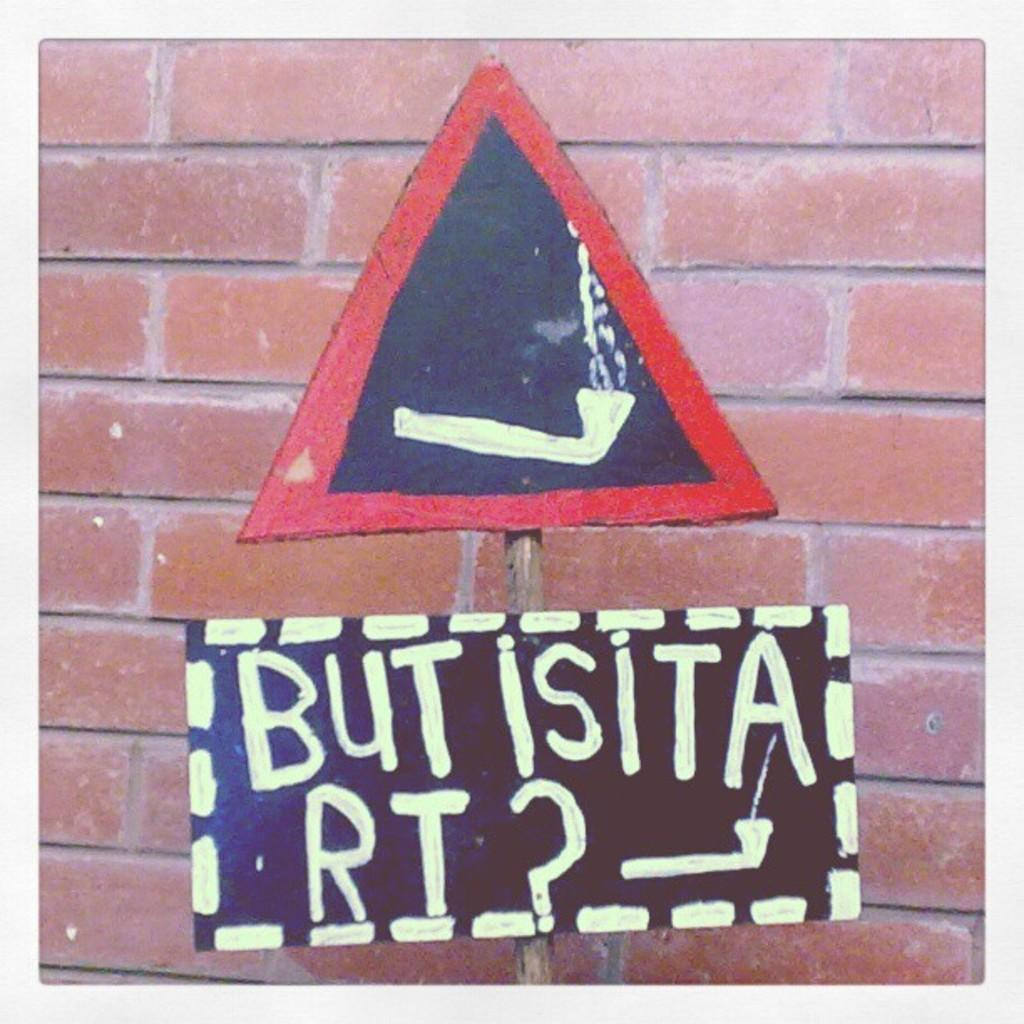What type of structure is visible in the image? There is a brick wall in the image. What is located in front of the brick wall? There is a sign board in front of the wall in the image. What type of voice can be heard coming from the sign board in the image? There is no voice or sound present in the image, as it is a static representation of a brick wall and a sign board. 